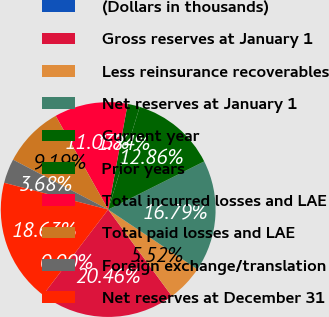<chart> <loc_0><loc_0><loc_500><loc_500><pie_chart><fcel>(Dollars in thousands)<fcel>Gross reserves at January 1<fcel>Less reinsurance recoverables<fcel>Net reserves at January 1<fcel>Current year<fcel>Prior years<fcel>Total incurred losses and LAE<fcel>Total paid losses and LAE<fcel>Foreign exchange/translation<fcel>Net reserves at December 31<nl><fcel>0.0%<fcel>20.46%<fcel>5.52%<fcel>16.79%<fcel>12.86%<fcel>1.84%<fcel>11.03%<fcel>9.19%<fcel>3.68%<fcel>18.63%<nl></chart> 